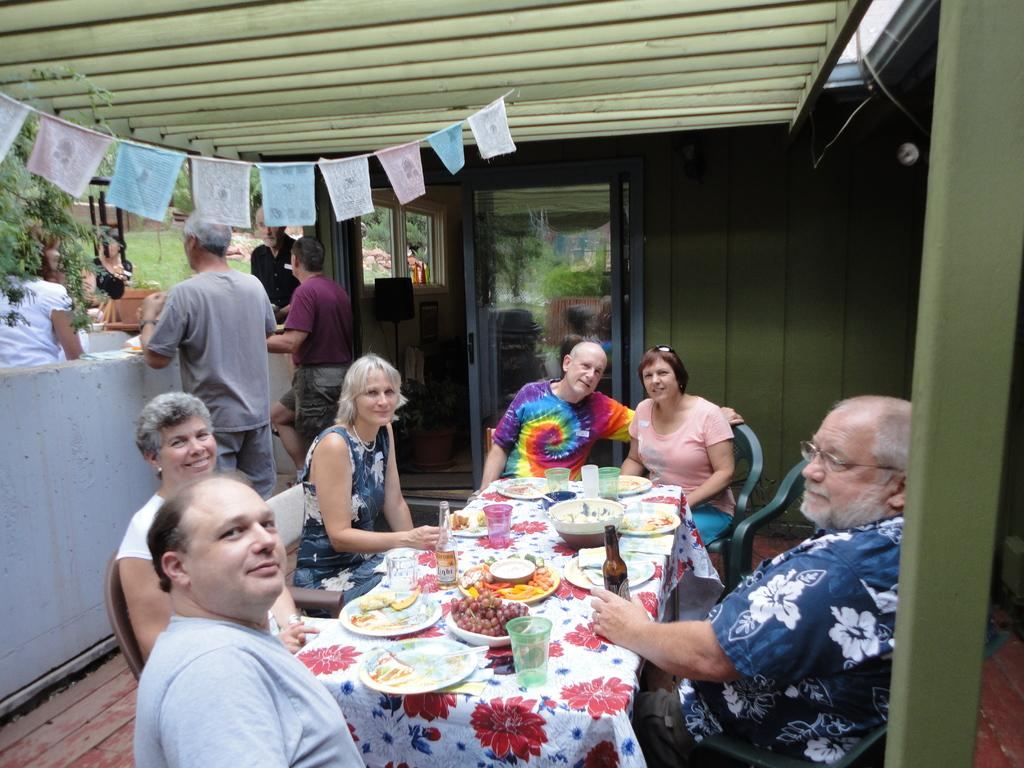How many people are in the image? There is a group of people in the image. What are the people doing in the image? The people are sitting at a table. What can be seen on the table in the image? The table has a wine bottle, fruits, and food. What is visible in the background of the image? There is a door in the backdrop of the image. What type of hook is hanging on the wall in the image? There is no hook visible in the image; it features a group of people sitting at a table with a wine bottle, fruits, and food, and a door in the background. 